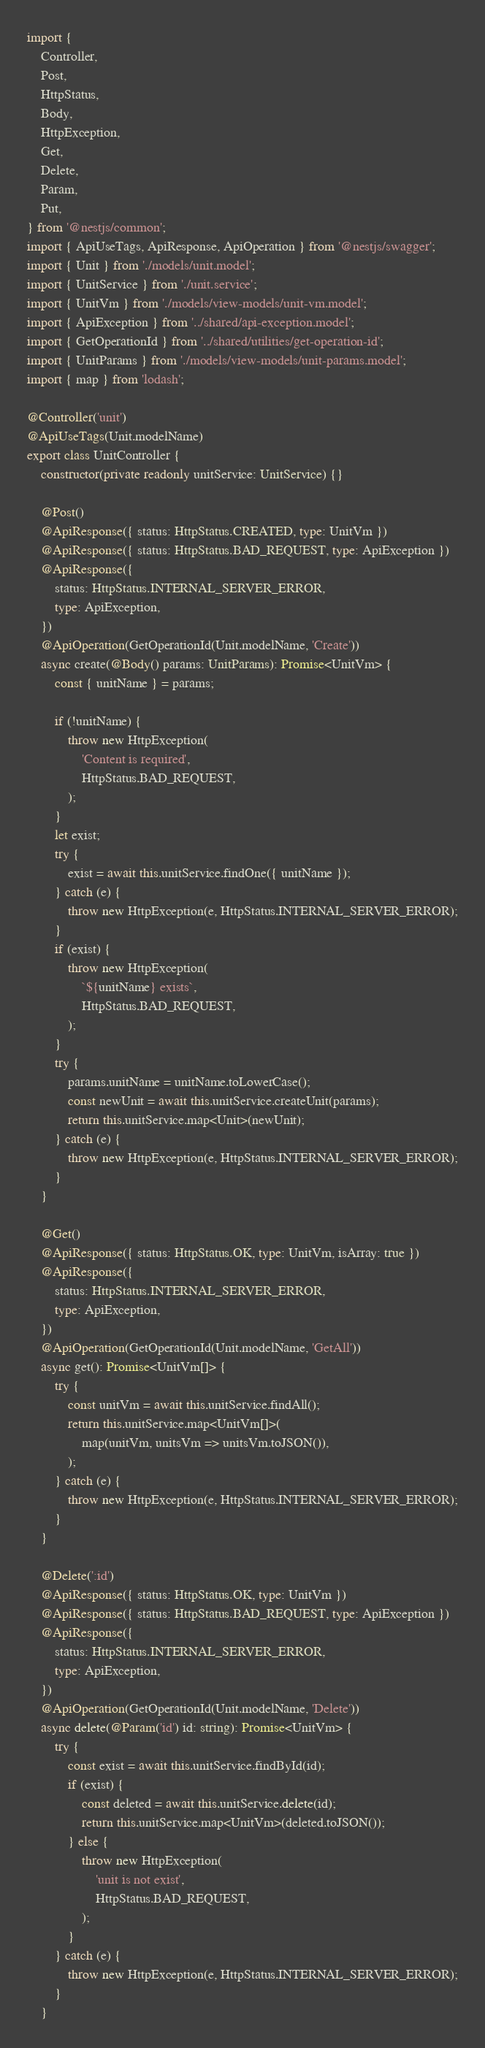Convert code to text. <code><loc_0><loc_0><loc_500><loc_500><_TypeScript_>import {
    Controller,
    Post,
    HttpStatus,
    Body,
    HttpException,
    Get,
    Delete,
    Param,
    Put,
} from '@nestjs/common';
import { ApiUseTags, ApiResponse, ApiOperation } from '@nestjs/swagger';
import { Unit } from './models/unit.model';
import { UnitService } from './unit.service';
import { UnitVm } from './models/view-models/unit-vm.model';
import { ApiException } from '../shared/api-exception.model';
import { GetOperationId } from '../shared/utilities/get-operation-id';
import { UnitParams } from './models/view-models/unit-params.model';
import { map } from 'lodash';

@Controller('unit')
@ApiUseTags(Unit.modelName)
export class UnitController {
    constructor(private readonly unitService: UnitService) {}

    @Post()
    @ApiResponse({ status: HttpStatus.CREATED, type: UnitVm })
    @ApiResponse({ status: HttpStatus.BAD_REQUEST, type: ApiException })
    @ApiResponse({
        status: HttpStatus.INTERNAL_SERVER_ERROR,
        type: ApiException,
    })
    @ApiOperation(GetOperationId(Unit.modelName, 'Create'))
    async create(@Body() params: UnitParams): Promise<UnitVm> {
        const { unitName } = params;

        if (!unitName) {
            throw new HttpException(
                'Content is required',
                HttpStatus.BAD_REQUEST,
            );
        }
        let exist;
        try {
            exist = await this.unitService.findOne({ unitName });
        } catch (e) {
            throw new HttpException(e, HttpStatus.INTERNAL_SERVER_ERROR);
        }
        if (exist) {
            throw new HttpException(
                `${unitName} exists`,
                HttpStatus.BAD_REQUEST,
            );
        }
        try {
            params.unitName = unitName.toLowerCase();
            const newUnit = await this.unitService.createUnit(params);
            return this.unitService.map<Unit>(newUnit);
        } catch (e) {
            throw new HttpException(e, HttpStatus.INTERNAL_SERVER_ERROR);
        }
    }

    @Get()
    @ApiResponse({ status: HttpStatus.OK, type: UnitVm, isArray: true })
    @ApiResponse({
        status: HttpStatus.INTERNAL_SERVER_ERROR,
        type: ApiException,
    })
    @ApiOperation(GetOperationId(Unit.modelName, 'GetAll'))
    async get(): Promise<UnitVm[]> {
        try {
            const unitVm = await this.unitService.findAll();
            return this.unitService.map<UnitVm[]>(
                map(unitVm, unitsVm => unitsVm.toJSON()),
            );
        } catch (e) {
            throw new HttpException(e, HttpStatus.INTERNAL_SERVER_ERROR);
        }
    }

    @Delete(':id')
    @ApiResponse({ status: HttpStatus.OK, type: UnitVm })
    @ApiResponse({ status: HttpStatus.BAD_REQUEST, type: ApiException })
    @ApiResponse({
        status: HttpStatus.INTERNAL_SERVER_ERROR,
        type: ApiException,
    })
    @ApiOperation(GetOperationId(Unit.modelName, 'Delete'))
    async delete(@Param('id') id: string): Promise<UnitVm> {
        try {
            const exist = await this.unitService.findById(id);
            if (exist) {
                const deleted = await this.unitService.delete(id);
                return this.unitService.map<UnitVm>(deleted.toJSON());
            } else {
                throw new HttpException(
                    'unit is not exist',
                    HttpStatus.BAD_REQUEST,
                );
            }
        } catch (e) {
            throw new HttpException(e, HttpStatus.INTERNAL_SERVER_ERROR);
        }
    }
</code> 